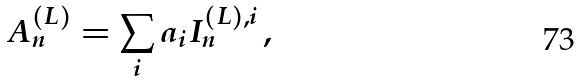Convert formula to latex. <formula><loc_0><loc_0><loc_500><loc_500>A _ { n } ^ { ( L ) } = \sum _ { i } a _ { i } I _ { n } ^ { ( L ) , i } \, ,</formula> 